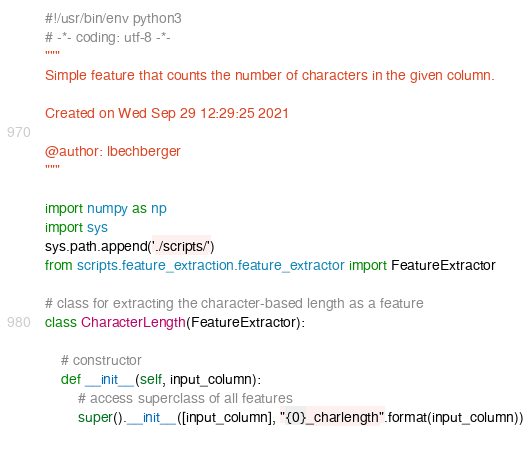<code> <loc_0><loc_0><loc_500><loc_500><_Python_>#!/usr/bin/env python3
# -*- coding: utf-8 -*-
"""
Simple feature that counts the number of characters in the given column.

Created on Wed Sep 29 12:29:25 2021

@author: lbechberger
"""

import numpy as np
import sys
sys.path.append('./scripts/')
from scripts.feature_extraction.feature_extractor import FeatureExtractor

# class for extracting the character-based length as a feature
class CharacterLength(FeatureExtractor):
    
    # constructor
    def __init__(self, input_column):
        # access superclass of all features
        super().__init__([input_column], "{0}_charlength".format(input_column))
    </code> 